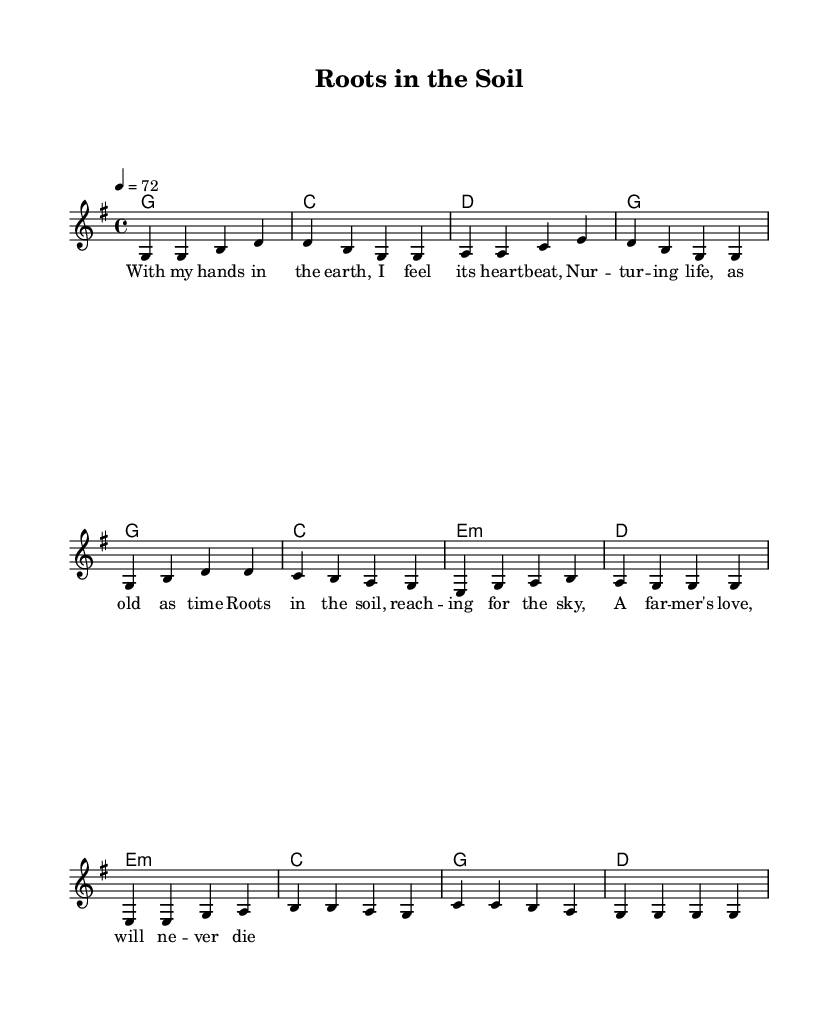What is the key signature of this music? The key signature is G major, which has one sharp (F#) indicated at the beginning of the staff.
Answer: G major What is the time signature of this music? The time signature is 4/4, meaning there are four beats in each measure and the quarter note gets one beat.
Answer: 4/4 What is the tempo marking for this piece? The tempo marking is "4 = 72", which indicates that there will be 72 quarter-note beats per minute.
Answer: 72 How many verses are included in the composition? There is one verse indicated in the score, followed by a chorus, which repeats the same lyrics.
Answer: One verse What is the last chord of the bridge section? The last chord of the bridge section is D major, as indicated in the chord progression in that part of the score.
Answer: D What theme is expressed in this song? The song expresses a connection between farmers and the land, highlighting themes of nurturing and love for the earth.
Answer: Connection to the land 